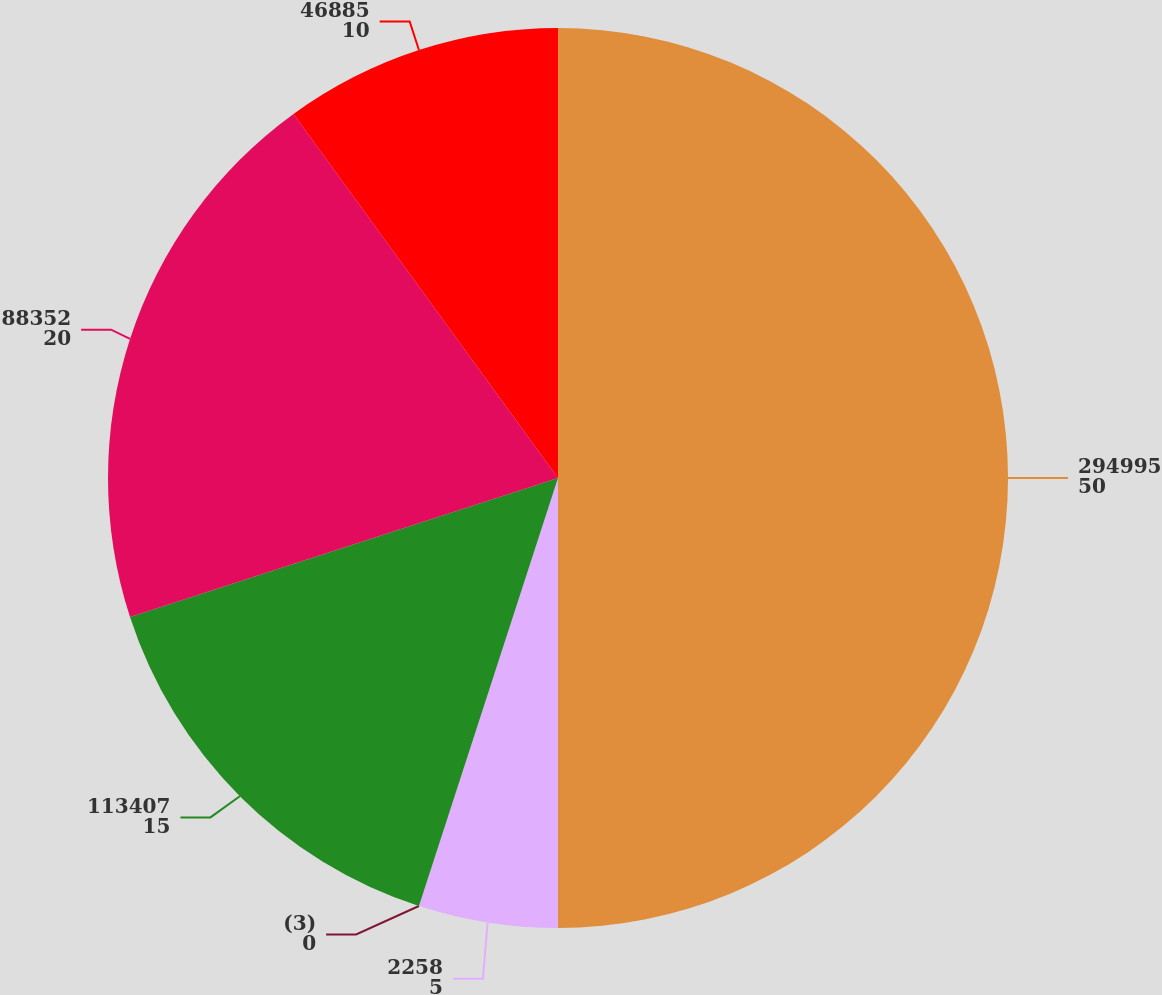Convert chart to OTSL. <chart><loc_0><loc_0><loc_500><loc_500><pie_chart><fcel>294995<fcel>2258<fcel>(3)<fcel>113407<fcel>88352<fcel>46885<nl><fcel>50.0%<fcel>5.0%<fcel>0.0%<fcel>15.0%<fcel>20.0%<fcel>10.0%<nl></chart> 